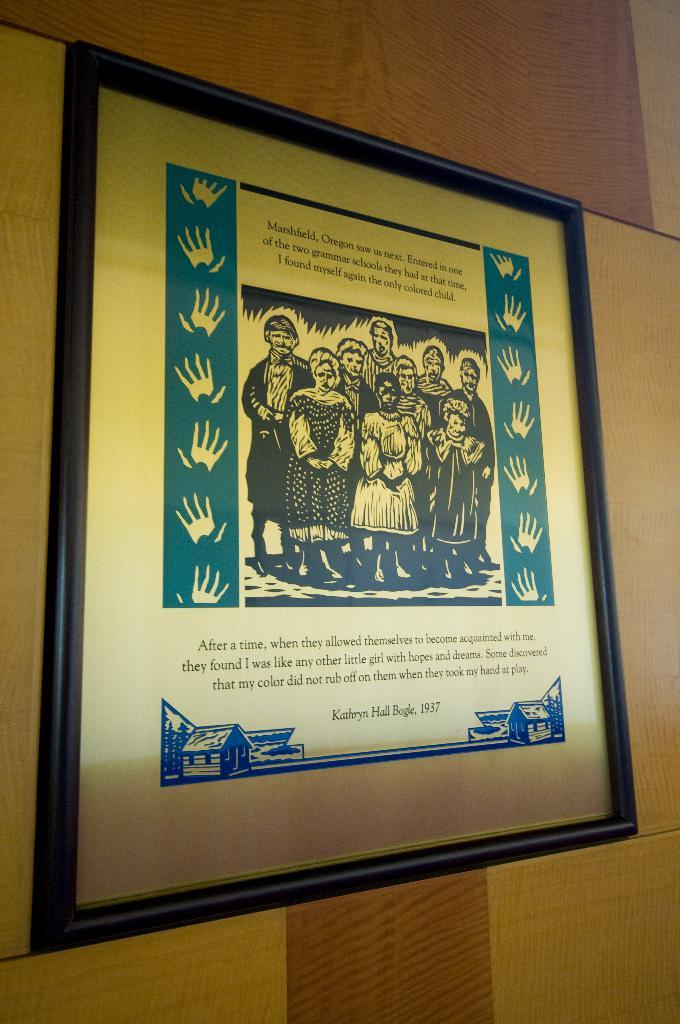<image>
Relay a brief, clear account of the picture shown. Words from Kathryn Hall Bogle from 1937 are displayed in a frame. 